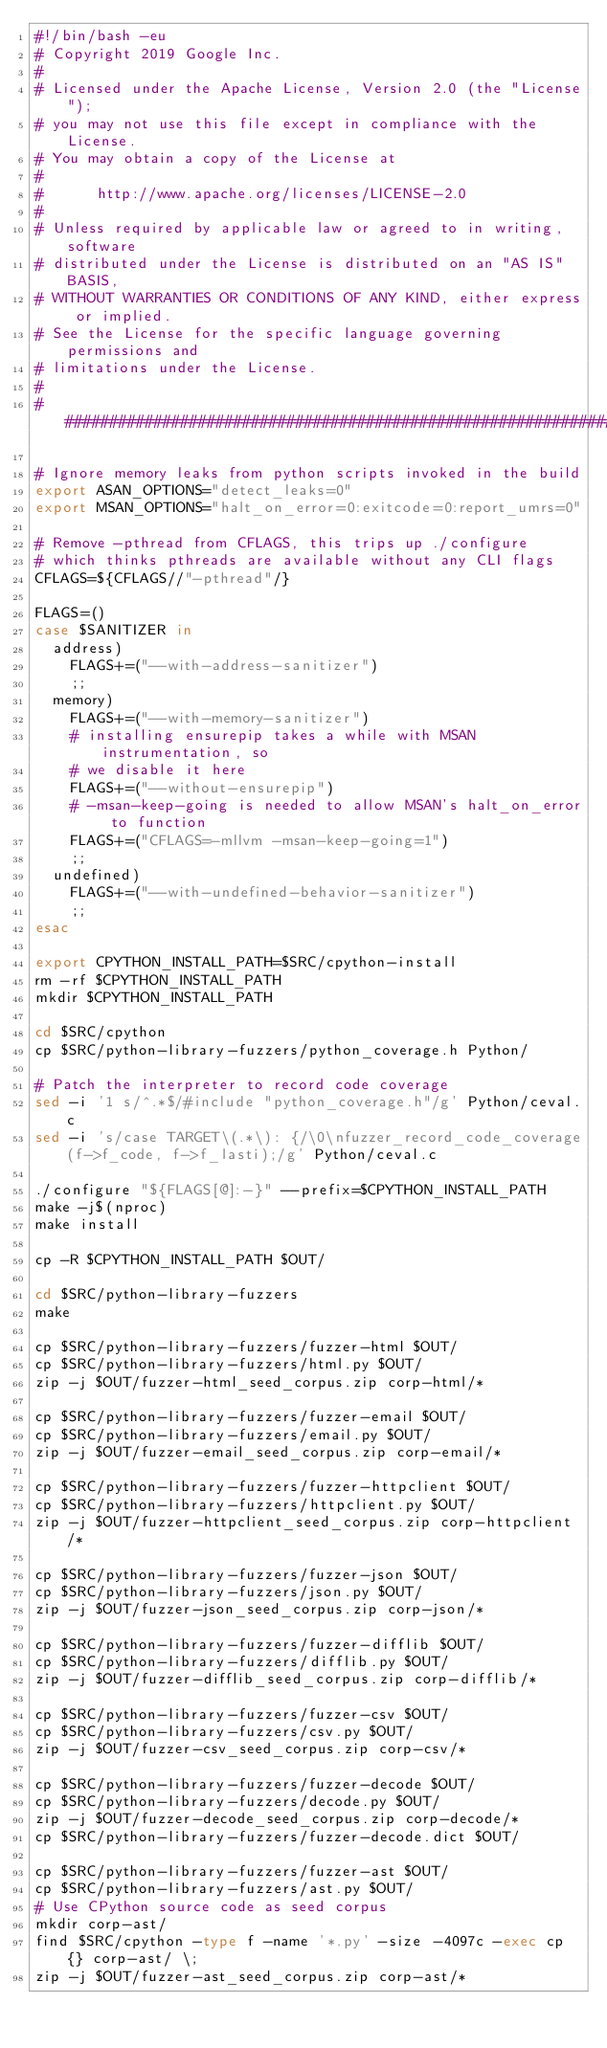Convert code to text. <code><loc_0><loc_0><loc_500><loc_500><_Bash_>#!/bin/bash -eu
# Copyright 2019 Google Inc.
#
# Licensed under the Apache License, Version 2.0 (the "License");
# you may not use this file except in compliance with the License.
# You may obtain a copy of the License at
#
#      http://www.apache.org/licenses/LICENSE-2.0
#
# Unless required by applicable law or agreed to in writing, software
# distributed under the License is distributed on an "AS IS" BASIS,
# WITHOUT WARRANTIES OR CONDITIONS OF ANY KIND, either express or implied.
# See the License for the specific language governing permissions and
# limitations under the License.
#
################################################################################

# Ignore memory leaks from python scripts invoked in the build
export ASAN_OPTIONS="detect_leaks=0"
export MSAN_OPTIONS="halt_on_error=0:exitcode=0:report_umrs=0"

# Remove -pthread from CFLAGS, this trips up ./configure
# which thinks pthreads are available without any CLI flags
CFLAGS=${CFLAGS//"-pthread"/}

FLAGS=()
case $SANITIZER in
  address)
    FLAGS+=("--with-address-sanitizer")
    ;;
  memory)
    FLAGS+=("--with-memory-sanitizer")
    # installing ensurepip takes a while with MSAN instrumentation, so
    # we disable it here
    FLAGS+=("--without-ensurepip")
    # -msan-keep-going is needed to allow MSAN's halt_on_error to function
    FLAGS+=("CFLAGS=-mllvm -msan-keep-going=1")
    ;;
  undefined)
    FLAGS+=("--with-undefined-behavior-sanitizer")
    ;;
esac

export CPYTHON_INSTALL_PATH=$SRC/cpython-install
rm -rf $CPYTHON_INSTALL_PATH
mkdir $CPYTHON_INSTALL_PATH

cd $SRC/cpython
cp $SRC/python-library-fuzzers/python_coverage.h Python/

# Patch the interpreter to record code coverage
sed -i '1 s/^.*$/#include "python_coverage.h"/g' Python/ceval.c
sed -i 's/case TARGET\(.*\): {/\0\nfuzzer_record_code_coverage(f->f_code, f->f_lasti);/g' Python/ceval.c

./configure "${FLAGS[@]:-}" --prefix=$CPYTHON_INSTALL_PATH
make -j$(nproc)
make install

cp -R $CPYTHON_INSTALL_PATH $OUT/

cd $SRC/python-library-fuzzers
make

cp $SRC/python-library-fuzzers/fuzzer-html $OUT/
cp $SRC/python-library-fuzzers/html.py $OUT/
zip -j $OUT/fuzzer-html_seed_corpus.zip corp-html/*

cp $SRC/python-library-fuzzers/fuzzer-email $OUT/
cp $SRC/python-library-fuzzers/email.py $OUT/
zip -j $OUT/fuzzer-email_seed_corpus.zip corp-email/*

cp $SRC/python-library-fuzzers/fuzzer-httpclient $OUT/
cp $SRC/python-library-fuzzers/httpclient.py $OUT/
zip -j $OUT/fuzzer-httpclient_seed_corpus.zip corp-httpclient/*

cp $SRC/python-library-fuzzers/fuzzer-json $OUT/
cp $SRC/python-library-fuzzers/json.py $OUT/
zip -j $OUT/fuzzer-json_seed_corpus.zip corp-json/*

cp $SRC/python-library-fuzzers/fuzzer-difflib $OUT/
cp $SRC/python-library-fuzzers/difflib.py $OUT/
zip -j $OUT/fuzzer-difflib_seed_corpus.zip corp-difflib/*

cp $SRC/python-library-fuzzers/fuzzer-csv $OUT/
cp $SRC/python-library-fuzzers/csv.py $OUT/
zip -j $OUT/fuzzer-csv_seed_corpus.zip corp-csv/*

cp $SRC/python-library-fuzzers/fuzzer-decode $OUT/
cp $SRC/python-library-fuzzers/decode.py $OUT/
zip -j $OUT/fuzzer-decode_seed_corpus.zip corp-decode/*
cp $SRC/python-library-fuzzers/fuzzer-decode.dict $OUT/

cp $SRC/python-library-fuzzers/fuzzer-ast $OUT/
cp $SRC/python-library-fuzzers/ast.py $OUT/
# Use CPython source code as seed corpus
mkdir corp-ast/
find $SRC/cpython -type f -name '*.py' -size -4097c -exec cp {} corp-ast/ \;
zip -j $OUT/fuzzer-ast_seed_corpus.zip corp-ast/*
</code> 